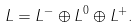Convert formula to latex. <formula><loc_0><loc_0><loc_500><loc_500>L = L ^ { - } \oplus L ^ { 0 } \oplus L ^ { + } .</formula> 